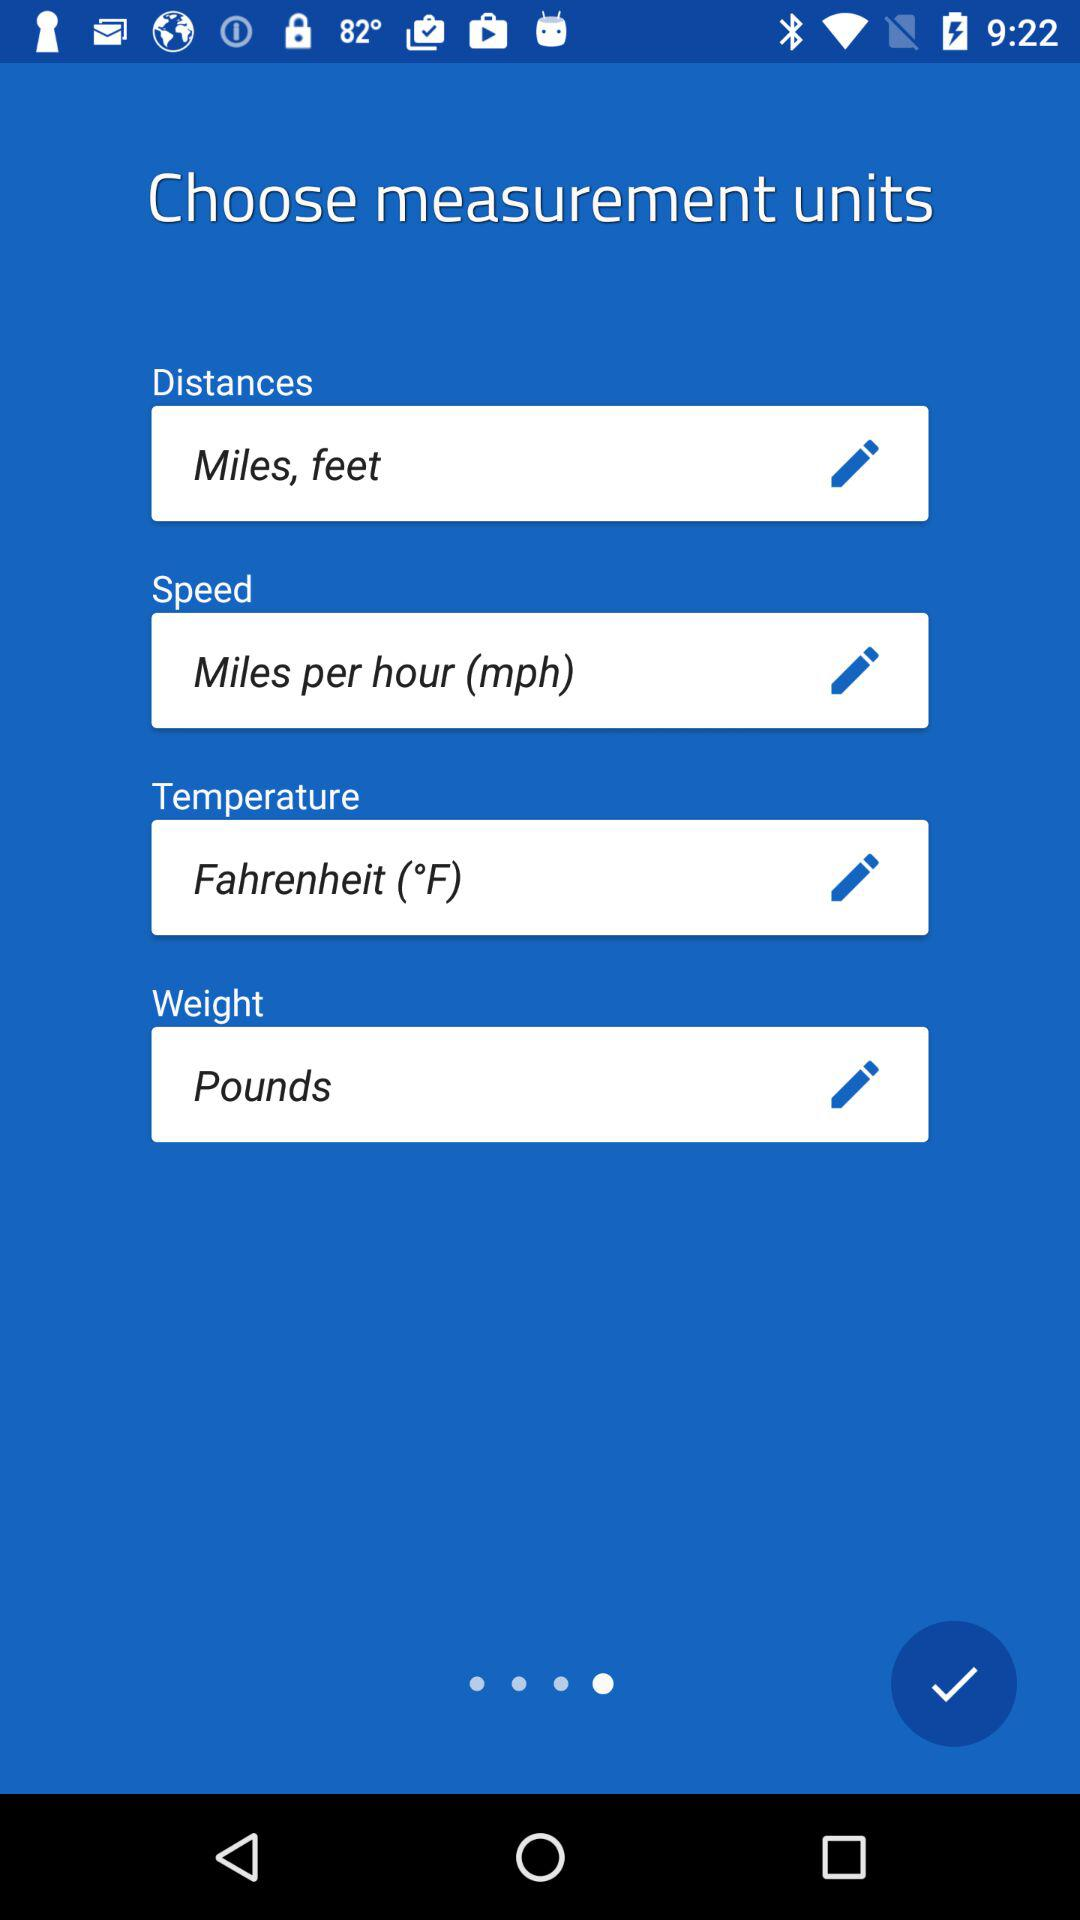What is the unit of temperature? The unit of temperature is Fahrenheit (°F). 